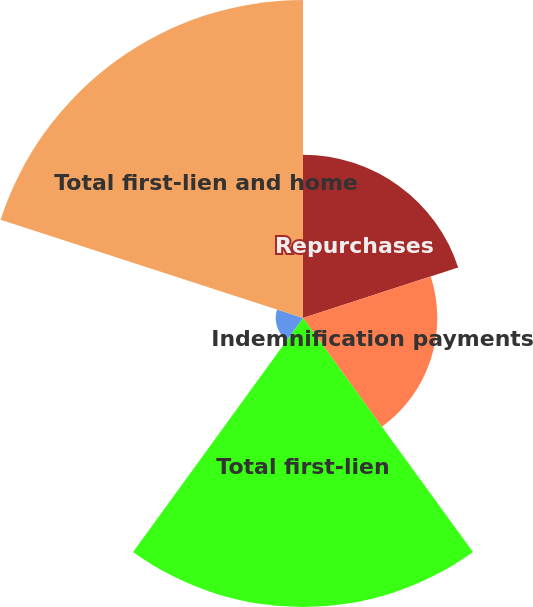<chart> <loc_0><loc_0><loc_500><loc_500><pie_chart><fcel>Repurchases<fcel>Indemnification payments<fcel>Total first-lien<fcel>Total home equity<fcel>Total first-lien and home<nl><fcel>17.51%<fcel>14.41%<fcel>31.02%<fcel>2.93%<fcel>34.12%<nl></chart> 